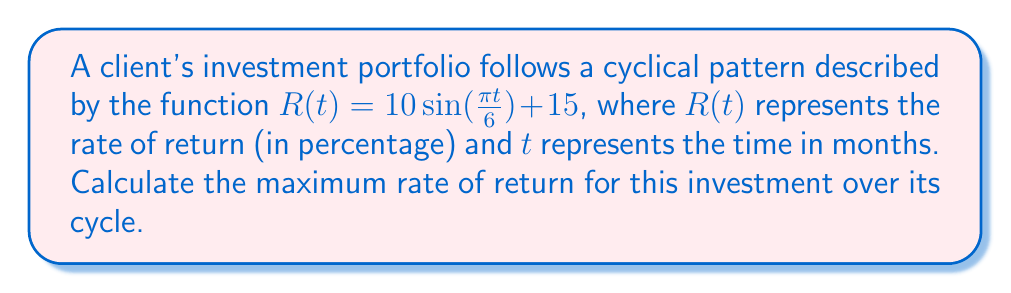Can you solve this math problem? To find the maximum rate of return, we need to identify the highest point of the sine function:

1) The general form of a sine function is:
   $f(t) = A\sin(Bt) + C$
   Where $A$ is the amplitude, $B$ is the angular frequency, and $C$ is the vertical shift.

2) In our function $R(t) = 10\sin(\frac{\pi t}{6}) + 15$:
   $A = 10$ (amplitude)
   $B = \frac{\pi}{6}$ (angular frequency)
   $C = 15$ (vertical shift)

3) The maximum value of $\sin(x)$ is 1, which occurs when $x = \frac{\pi}{2}$.

4) The maximum value of $A\sin(Bt)$ occurs when $Bt = \frac{\pi}{2}$.

5) The maximum of the entire function will be this value plus the vertical shift $C$.

6) Therefore, the maximum rate of return is:
   $R_{max} = A + C = 10 + 15 = 25$

Thus, the maximum rate of return is 25%.
Answer: 25% 